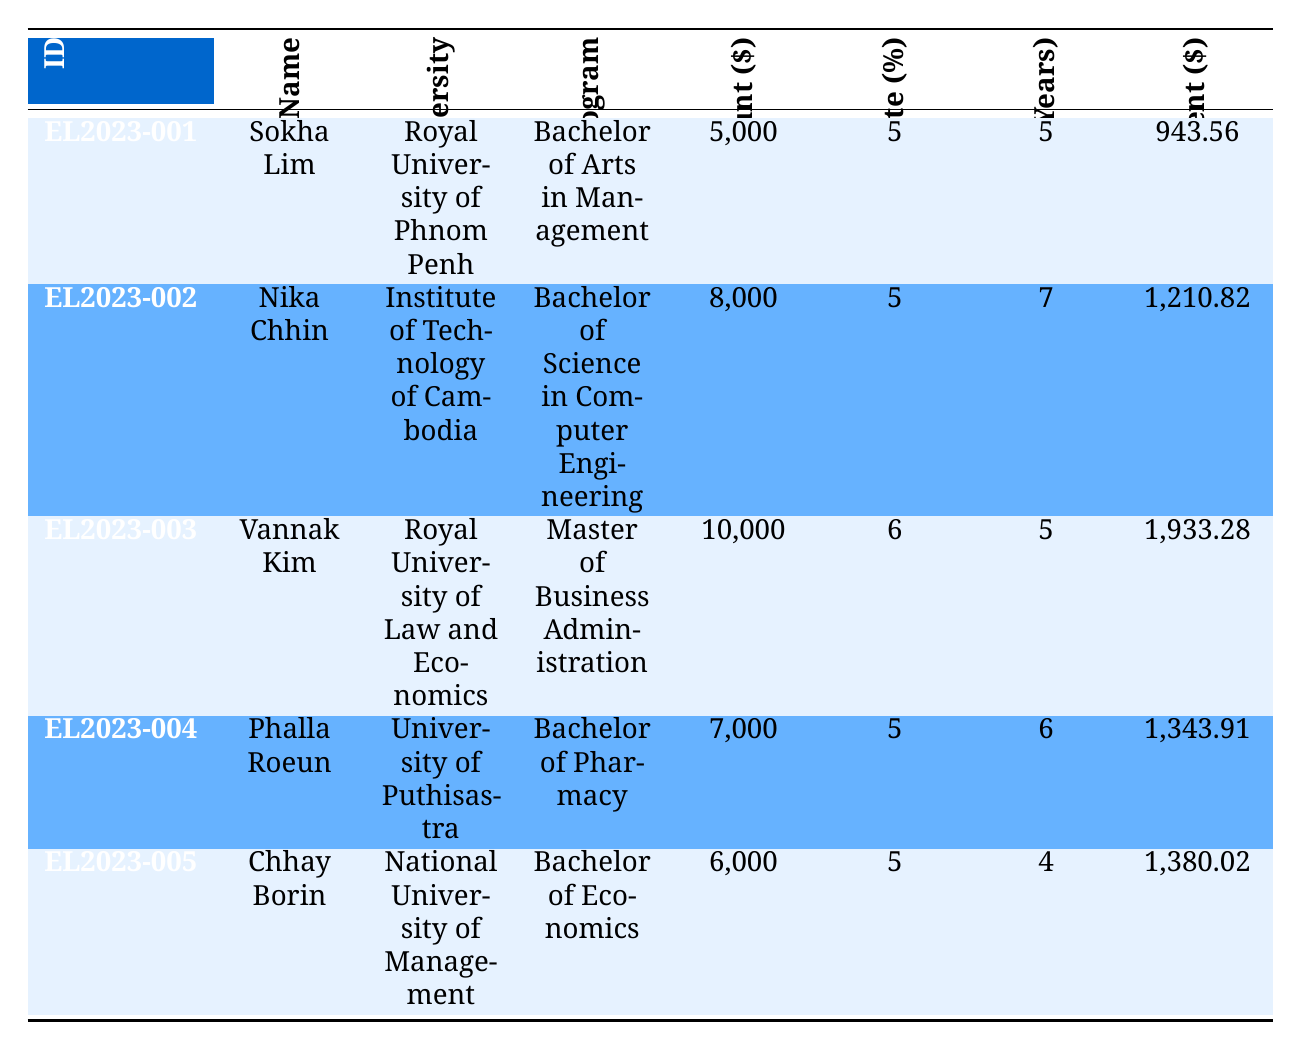What is the loan amount for Sokha Lim? The table indicates that the loan amount for Sokha Lim is listed under the "Loan Amount ($)" column corresponding to her entry. It shows 5,000.
Answer: 5,000 Which university is Vannak Kim attending? To find this information, I can look at the row for Vannak Kim in the table and refer to the "University" column which states "Royal University of Law and Economics."
Answer: Royal University of Law and Economics What is the total interest paid by Nika Chhin? The total interest amount for Nika Chhin can be found directly from her row in the "Total Interest Paid" column. It shows 21,190.65.
Answer: 21,190.65 What is the total payment for Chhay Borin's loan? Looking at Chhay Borin's entry in the table, I refer to the "Total Payment" column, which confirms that the total payment for his loan is 66,160.98.
Answer: 66,160.98 Which borrower has the highest monthly payment, and what is that amount? To find this, I can compare the "Monthly Payment ($)" values across all borrowers. Vannak Kim has the highest at 1,933.28.
Answer: Vannak Kim, 1,933.28 What is the average loan amount across all borrowers? I will sum the loan amounts: (5,000 + 8,000 + 10,000 + 7,000 + 6,000) = 36,000. Since there are 5 borrowers, the average loan amount is 36,000 / 5 = 7,200.
Answer: 7,200 Did any borrower take out a loan with an interest rate of 6%? To answer this, I check the "Interest Rate (%)" column for each borrower. I see that only Vannak Kim has a loan with an interest rate of 6%. Thus, the answer is yes.
Answer: Yes What is the difference in total payment between the loans taken by Sokha Lim and Vannak Kim? I first find the total payment for Sokha Lim (56,613.45) and Vannak Kim (115,996.80). The difference is 115,996.80 - 56,613.45 = 59,383.35.
Answer: 59,383.35 Which program has the lowest loan amount, and who is the borrower? I review the "Loan Amount ($)" column to find the lowest value, which is 5,000 associated with Sokha Lim studying for a Bachelor of Arts in Management.
Answer: Bachelor of Arts in Management, Sokha Lim How many borrowers have loans for a duration of more than 5 years? I check the "Term (Years)" for each borrower: Nika Chhin (7 years) and Phalla Roeun (6 years) have more than 5 years. Thus, there are 2 borrowers.
Answer: 2 